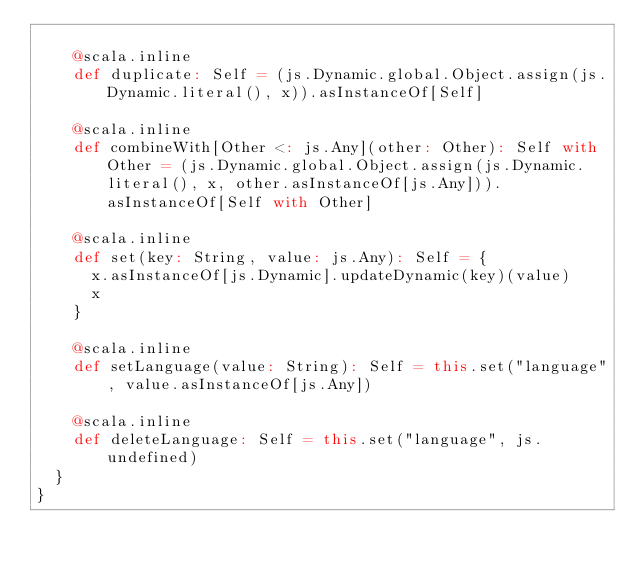<code> <loc_0><loc_0><loc_500><loc_500><_Scala_>    
    @scala.inline
    def duplicate: Self = (js.Dynamic.global.Object.assign(js.Dynamic.literal(), x)).asInstanceOf[Self]
    
    @scala.inline
    def combineWith[Other <: js.Any](other: Other): Self with Other = (js.Dynamic.global.Object.assign(js.Dynamic.literal(), x, other.asInstanceOf[js.Any])).asInstanceOf[Self with Other]
    
    @scala.inline
    def set(key: String, value: js.Any): Self = {
      x.asInstanceOf[js.Dynamic].updateDynamic(key)(value)
      x
    }
    
    @scala.inline
    def setLanguage(value: String): Self = this.set("language", value.asInstanceOf[js.Any])
    
    @scala.inline
    def deleteLanguage: Self = this.set("language", js.undefined)
  }
}
</code> 